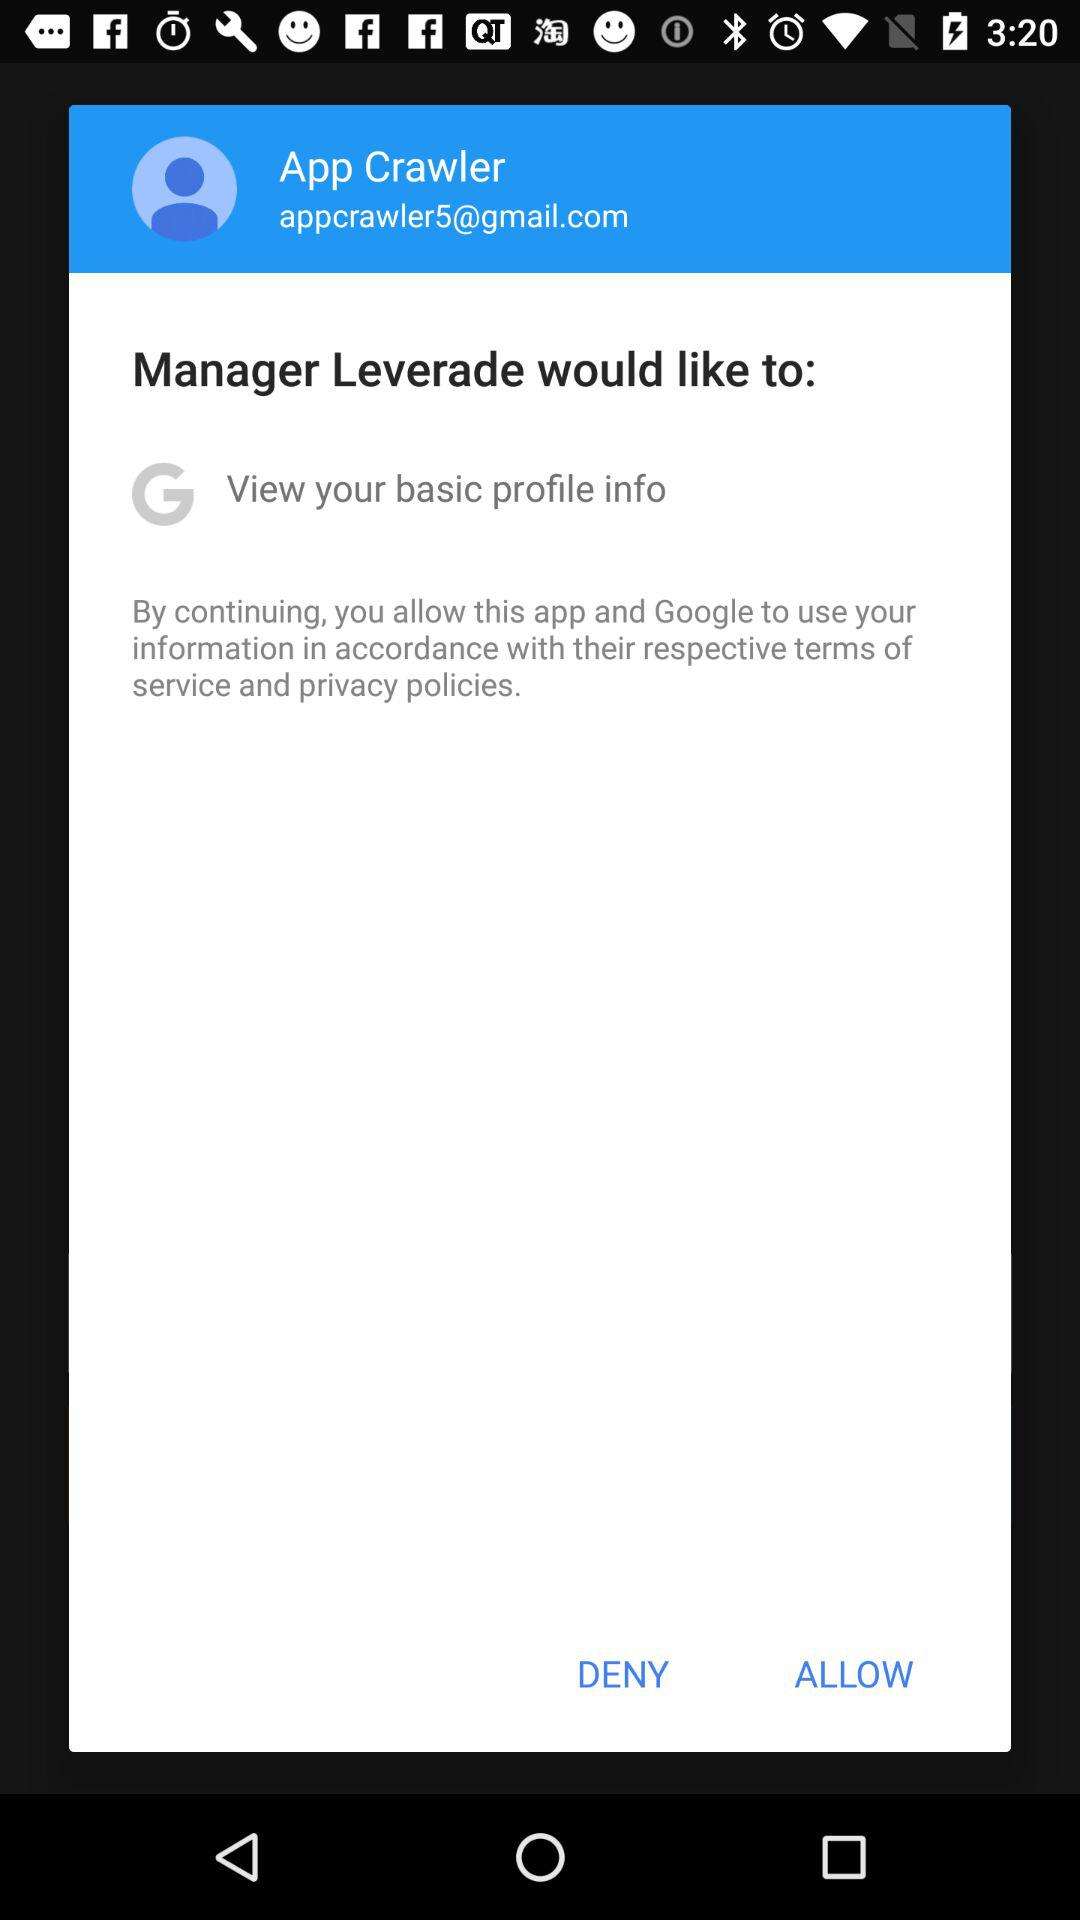What is the user name? The user name is App Crawler. 